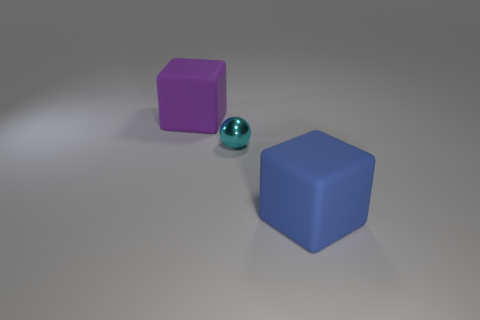Are there fewer tiny metallic cubes than large purple matte objects?
Keep it short and to the point. Yes. Do the tiny thing and the big blue thing have the same material?
Make the answer very short. No. What number of other things are the same size as the blue thing?
Make the answer very short. 1. There is a large matte thing left of the big thing that is to the right of the cyan shiny sphere; what color is it?
Provide a short and direct response. Purple. How many other objects are the same shape as the purple object?
Make the answer very short. 1. Are there any red cubes made of the same material as the blue thing?
Make the answer very short. No. There is a purple thing that is the same size as the blue matte cube; what is it made of?
Give a very brief answer. Rubber. What color is the matte cube that is in front of the cube that is behind the big object that is in front of the tiny cyan sphere?
Your answer should be very brief. Blue. Does the matte object on the right side of the purple thing have the same shape as the large matte object behind the big blue matte block?
Ensure brevity in your answer.  Yes. What number of blue rubber things are there?
Your answer should be very brief. 1. 